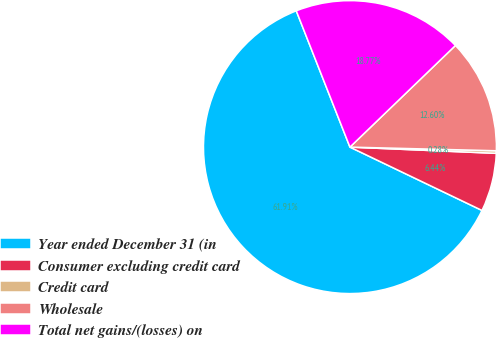<chart> <loc_0><loc_0><loc_500><loc_500><pie_chart><fcel>Year ended December 31 (in<fcel>Consumer excluding credit card<fcel>Credit card<fcel>Wholesale<fcel>Total net gains/(losses) on<nl><fcel>61.91%<fcel>6.44%<fcel>0.28%<fcel>12.6%<fcel>18.77%<nl></chart> 